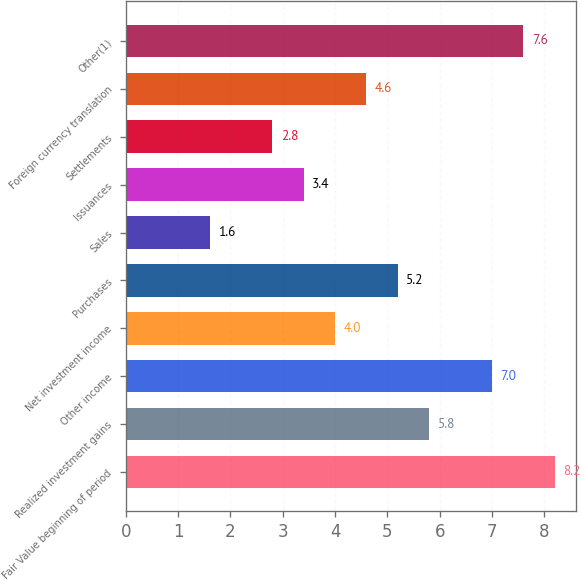<chart> <loc_0><loc_0><loc_500><loc_500><bar_chart><fcel>Fair Value beginning of period<fcel>Realized investment gains<fcel>Other income<fcel>Net investment income<fcel>Purchases<fcel>Sales<fcel>Issuances<fcel>Settlements<fcel>Foreign currency translation<fcel>Other(1)<nl><fcel>8.2<fcel>5.8<fcel>7<fcel>4<fcel>5.2<fcel>1.6<fcel>3.4<fcel>2.8<fcel>4.6<fcel>7.6<nl></chart> 